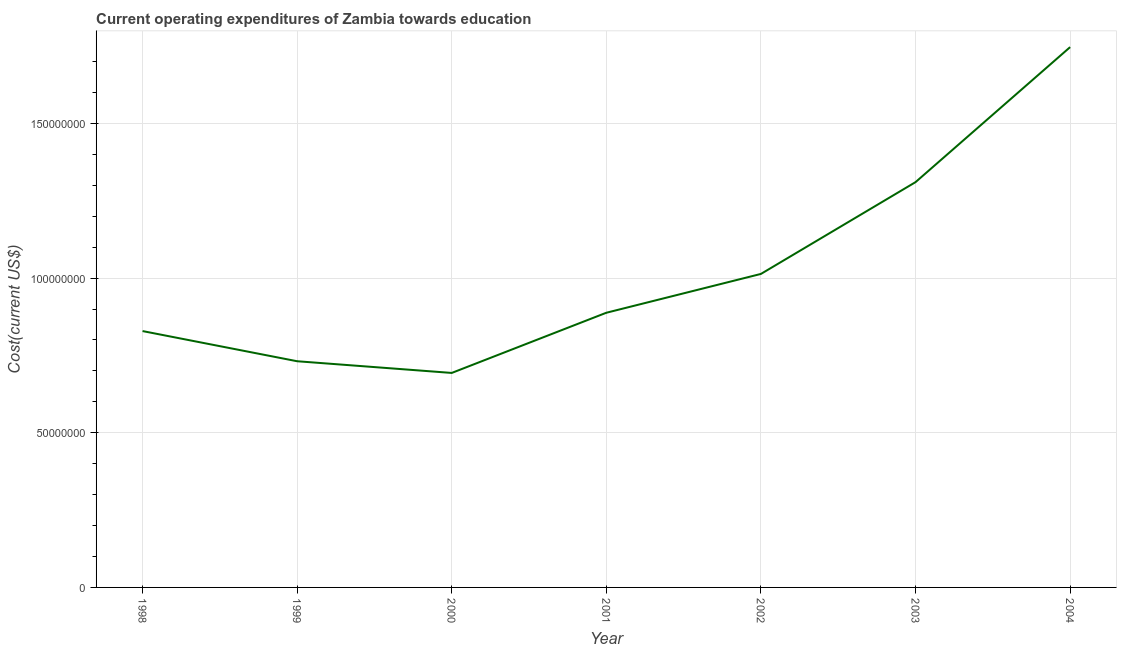What is the education expenditure in 1998?
Your answer should be very brief. 8.29e+07. Across all years, what is the maximum education expenditure?
Offer a terse response. 1.75e+08. Across all years, what is the minimum education expenditure?
Offer a very short reply. 6.93e+07. In which year was the education expenditure maximum?
Ensure brevity in your answer.  2004. What is the sum of the education expenditure?
Your response must be concise. 7.21e+08. What is the difference between the education expenditure in 1998 and 2002?
Give a very brief answer. -1.85e+07. What is the average education expenditure per year?
Keep it short and to the point. 1.03e+08. What is the median education expenditure?
Provide a succinct answer. 8.88e+07. In how many years, is the education expenditure greater than 20000000 US$?
Give a very brief answer. 7. Do a majority of the years between 2001 and 2002 (inclusive) have education expenditure greater than 90000000 US$?
Give a very brief answer. No. What is the ratio of the education expenditure in 1998 to that in 2004?
Your response must be concise. 0.47. Is the education expenditure in 2002 less than that in 2003?
Offer a very short reply. Yes. Is the difference between the education expenditure in 2003 and 2004 greater than the difference between any two years?
Offer a very short reply. No. What is the difference between the highest and the second highest education expenditure?
Give a very brief answer. 4.36e+07. Is the sum of the education expenditure in 2001 and 2004 greater than the maximum education expenditure across all years?
Your response must be concise. Yes. What is the difference between the highest and the lowest education expenditure?
Ensure brevity in your answer.  1.05e+08. How many years are there in the graph?
Your answer should be very brief. 7. What is the difference between two consecutive major ticks on the Y-axis?
Offer a very short reply. 5.00e+07. Does the graph contain grids?
Provide a short and direct response. Yes. What is the title of the graph?
Give a very brief answer. Current operating expenditures of Zambia towards education. What is the label or title of the X-axis?
Your answer should be compact. Year. What is the label or title of the Y-axis?
Keep it short and to the point. Cost(current US$). What is the Cost(current US$) in 1998?
Make the answer very short. 8.29e+07. What is the Cost(current US$) in 1999?
Give a very brief answer. 7.31e+07. What is the Cost(current US$) in 2000?
Give a very brief answer. 6.93e+07. What is the Cost(current US$) in 2001?
Offer a very short reply. 8.88e+07. What is the Cost(current US$) in 2002?
Offer a terse response. 1.01e+08. What is the Cost(current US$) in 2003?
Make the answer very short. 1.31e+08. What is the Cost(current US$) of 2004?
Your answer should be very brief. 1.75e+08. What is the difference between the Cost(current US$) in 1998 and 1999?
Your answer should be compact. 9.76e+06. What is the difference between the Cost(current US$) in 1998 and 2000?
Offer a terse response. 1.35e+07. What is the difference between the Cost(current US$) in 1998 and 2001?
Your response must be concise. -5.92e+06. What is the difference between the Cost(current US$) in 1998 and 2002?
Make the answer very short. -1.85e+07. What is the difference between the Cost(current US$) in 1998 and 2003?
Keep it short and to the point. -4.81e+07. What is the difference between the Cost(current US$) in 1998 and 2004?
Give a very brief answer. -9.18e+07. What is the difference between the Cost(current US$) in 1999 and 2000?
Offer a very short reply. 3.78e+06. What is the difference between the Cost(current US$) in 1999 and 2001?
Keep it short and to the point. -1.57e+07. What is the difference between the Cost(current US$) in 1999 and 2002?
Provide a succinct answer. -2.82e+07. What is the difference between the Cost(current US$) in 1999 and 2003?
Your response must be concise. -5.79e+07. What is the difference between the Cost(current US$) in 1999 and 2004?
Offer a terse response. -1.02e+08. What is the difference between the Cost(current US$) in 2000 and 2001?
Make the answer very short. -1.95e+07. What is the difference between the Cost(current US$) in 2000 and 2002?
Provide a short and direct response. -3.20e+07. What is the difference between the Cost(current US$) in 2000 and 2003?
Your answer should be very brief. -6.17e+07. What is the difference between the Cost(current US$) in 2000 and 2004?
Offer a very short reply. -1.05e+08. What is the difference between the Cost(current US$) in 2001 and 2002?
Keep it short and to the point. -1.25e+07. What is the difference between the Cost(current US$) in 2001 and 2003?
Make the answer very short. -4.22e+07. What is the difference between the Cost(current US$) in 2001 and 2004?
Offer a very short reply. -8.59e+07. What is the difference between the Cost(current US$) in 2002 and 2003?
Your answer should be very brief. -2.97e+07. What is the difference between the Cost(current US$) in 2002 and 2004?
Offer a very short reply. -7.33e+07. What is the difference between the Cost(current US$) in 2003 and 2004?
Offer a very short reply. -4.36e+07. What is the ratio of the Cost(current US$) in 1998 to that in 1999?
Give a very brief answer. 1.13. What is the ratio of the Cost(current US$) in 1998 to that in 2000?
Keep it short and to the point. 1.2. What is the ratio of the Cost(current US$) in 1998 to that in 2001?
Give a very brief answer. 0.93. What is the ratio of the Cost(current US$) in 1998 to that in 2002?
Your response must be concise. 0.82. What is the ratio of the Cost(current US$) in 1998 to that in 2003?
Your answer should be very brief. 0.63. What is the ratio of the Cost(current US$) in 1998 to that in 2004?
Your answer should be compact. 0.47. What is the ratio of the Cost(current US$) in 1999 to that in 2000?
Your response must be concise. 1.05. What is the ratio of the Cost(current US$) in 1999 to that in 2001?
Offer a very short reply. 0.82. What is the ratio of the Cost(current US$) in 1999 to that in 2002?
Provide a short and direct response. 0.72. What is the ratio of the Cost(current US$) in 1999 to that in 2003?
Give a very brief answer. 0.56. What is the ratio of the Cost(current US$) in 1999 to that in 2004?
Provide a succinct answer. 0.42. What is the ratio of the Cost(current US$) in 2000 to that in 2001?
Give a very brief answer. 0.78. What is the ratio of the Cost(current US$) in 2000 to that in 2002?
Keep it short and to the point. 0.68. What is the ratio of the Cost(current US$) in 2000 to that in 2003?
Your response must be concise. 0.53. What is the ratio of the Cost(current US$) in 2000 to that in 2004?
Your answer should be compact. 0.4. What is the ratio of the Cost(current US$) in 2001 to that in 2002?
Your answer should be very brief. 0.88. What is the ratio of the Cost(current US$) in 2001 to that in 2003?
Provide a short and direct response. 0.68. What is the ratio of the Cost(current US$) in 2001 to that in 2004?
Your answer should be compact. 0.51. What is the ratio of the Cost(current US$) in 2002 to that in 2003?
Your answer should be compact. 0.77. What is the ratio of the Cost(current US$) in 2002 to that in 2004?
Your answer should be very brief. 0.58. 